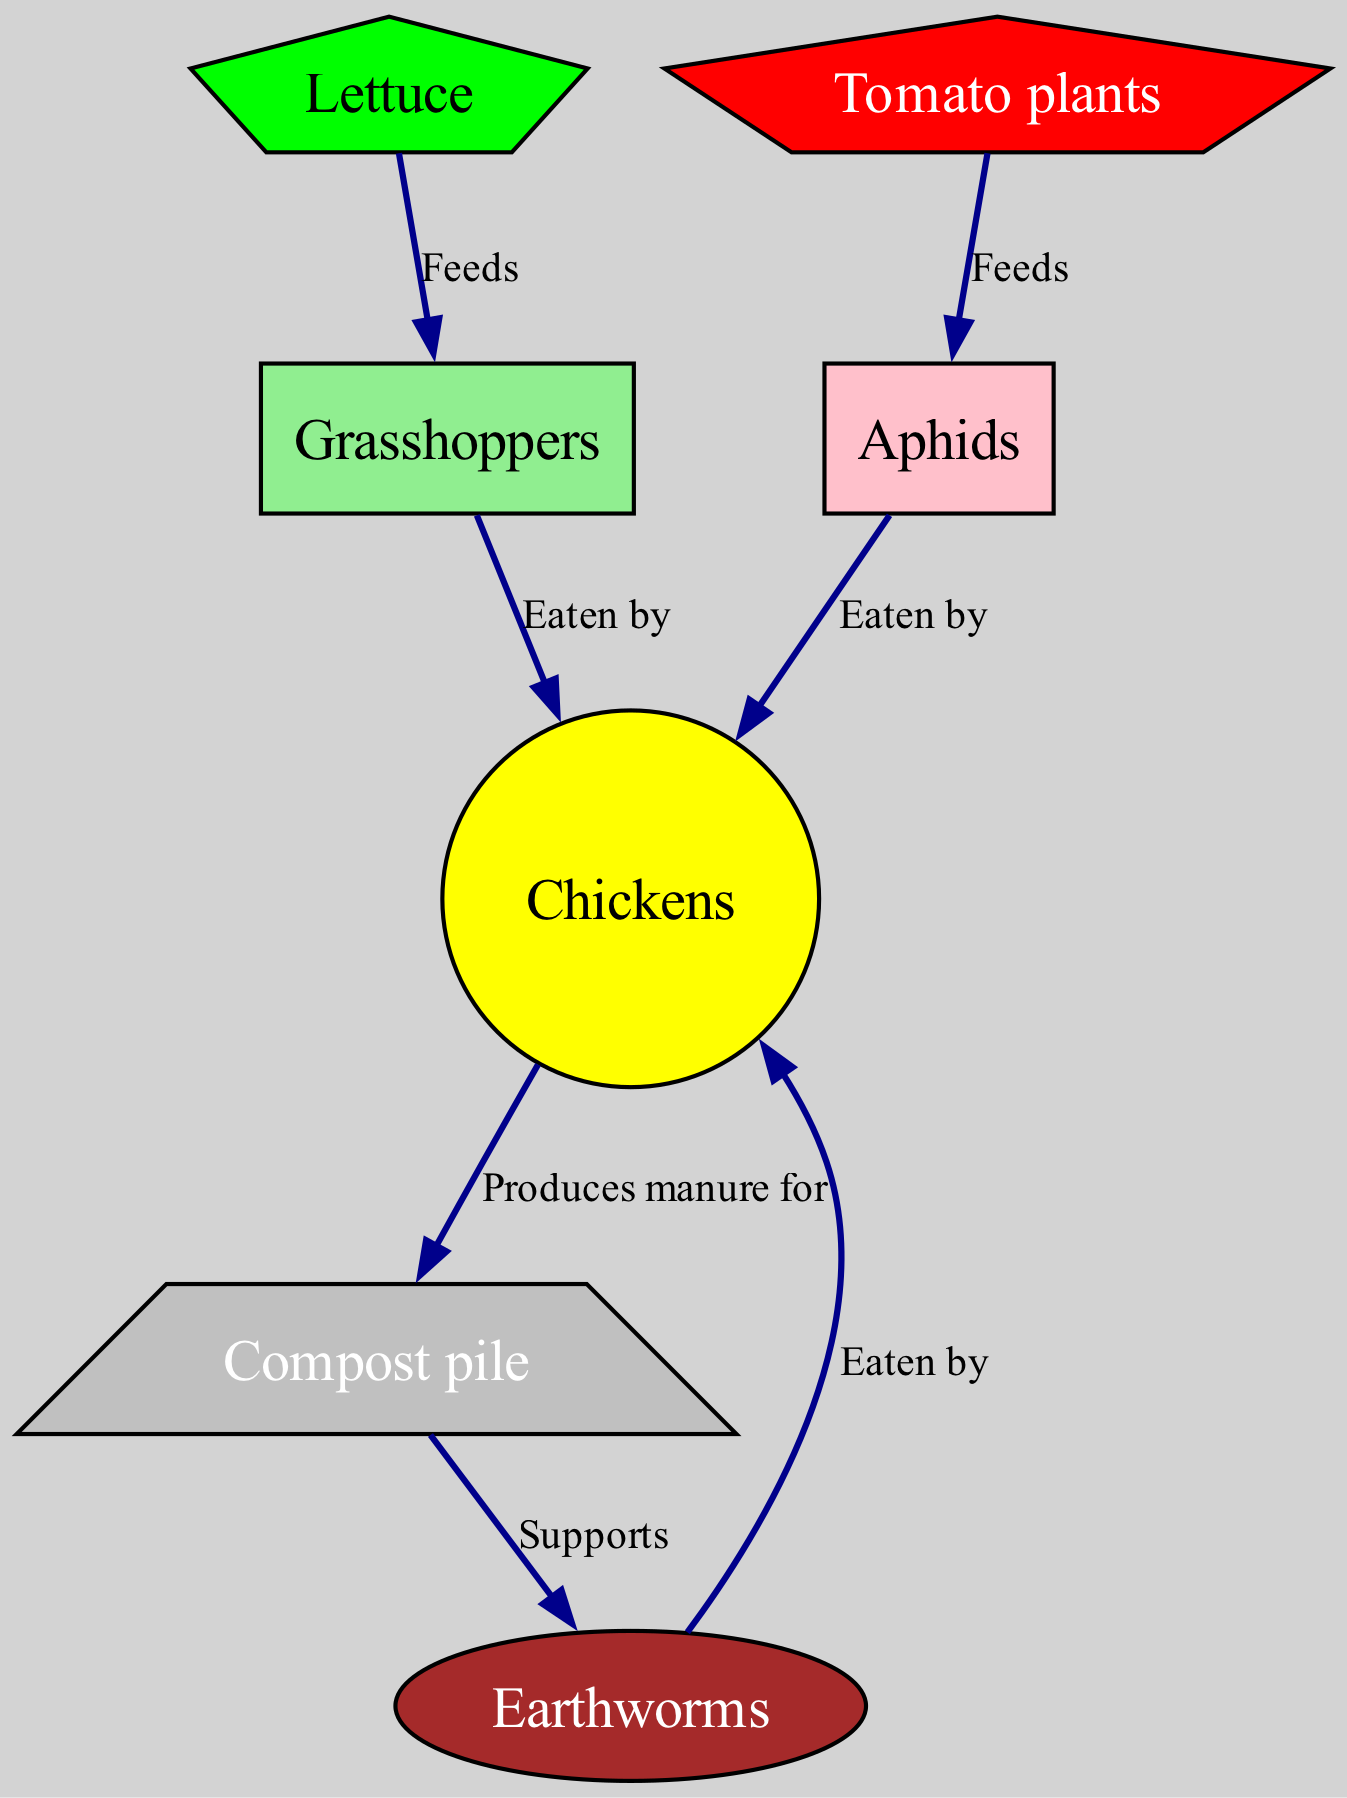What animal is eaten by both aphids and grasshoppers? The diagram shows connections where both aphids and grasshoppers have an arrow pointing towards the same node, which is "Chickens", indicating that both insects are prey for chickens.
Answer: Chickens How many nodes are present in the diagram? Counting the items in the nodes list, there are seven distinct nodes represented, which include chickens, insects, and plants.
Answer: 7 Which plant feeds grasshoppers? The diagram specifically points from "Lettuce" to "Grasshoppers,” indicating that grasshoppers derive their nutrients from this plant.
Answer: Lettuce What do chickens produce for the compost pile? The relationship between "Chickens" and "Compost pile" indicates a backward connection showing that chickens contribute manure to the compost pile.
Answer: Manure What supports the earthworms in the ecosystem? The diagram shows a supporting relationship where the "Compost pile" is connected to "Earthworms," thus indicating that the compost pile provides nutrients or habitat beneficial for earthworms.
Answer: Compost pile In what way do chickens interact with aphids? The diagram indicates a predatory relationship where aphids are an arrow pointing towards "Chickens," denoting that they are consumed by the chickens.
Answer: Eaten by How many feeding relationships are illustrated in the diagram? By analyzing the edges, it is identified that there are four feeding relationships directed towards the chicken from various insects, plus one from plants to insects, totaling five distinct feeding relationships.
Answer: 5 Which insect feeds on tomato plants? According to the diagram, there is a directed edge from "Tomato plants" to "Aphids," indicating that aphids feed on tomato plants.
Answer: Aphids Which element of the food web represents a decomposer? In the context of backyard ecology, "Earthworms" are represented in the diagram and serve the critical role of decomposers, as indicated by their reliance on the compost pile for support.
Answer: Earthworms 